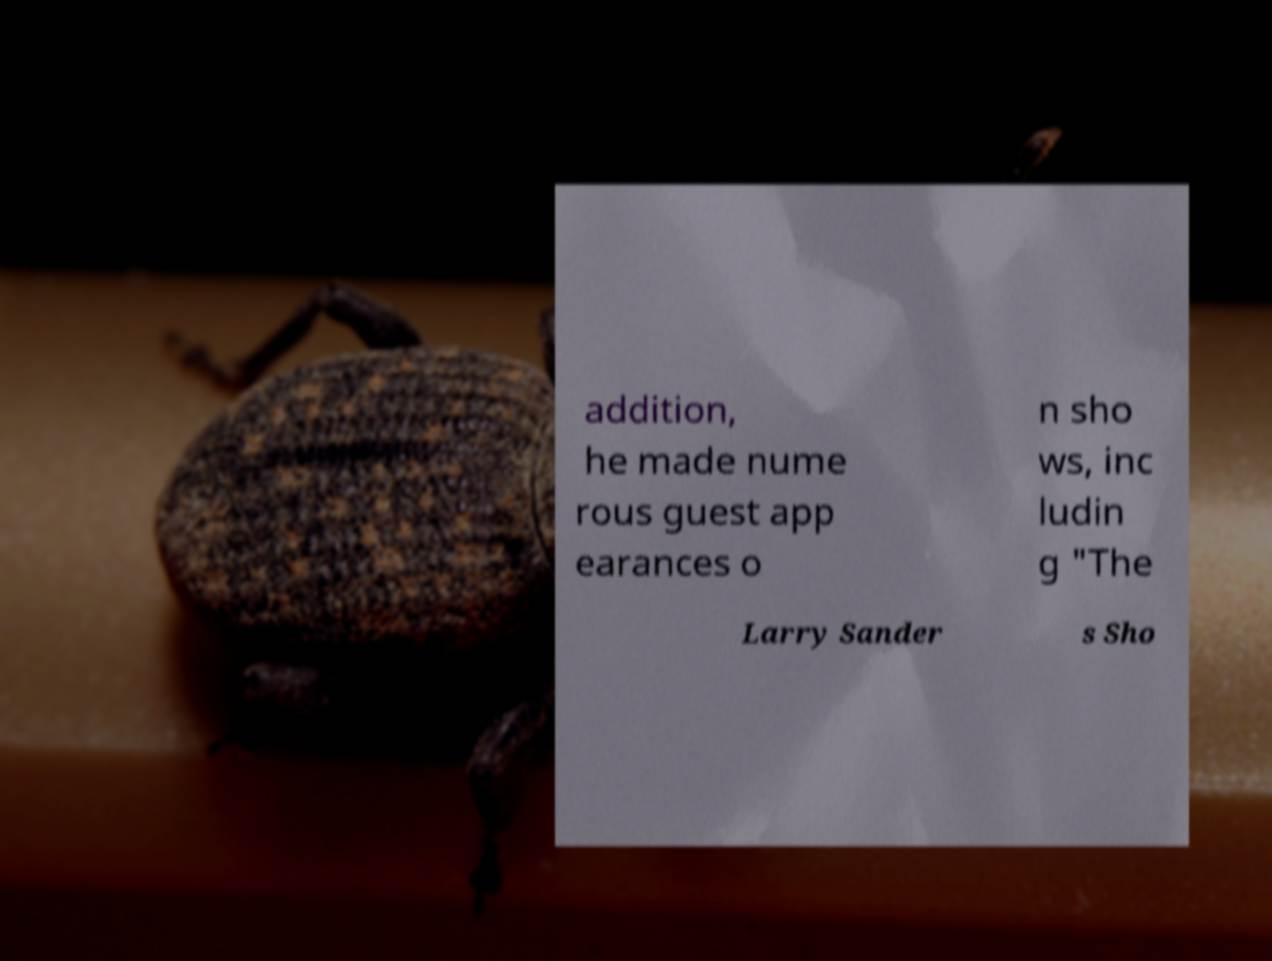What messages or text are displayed in this image? I need them in a readable, typed format. addition, he made nume rous guest app earances o n sho ws, inc ludin g "The Larry Sander s Sho 